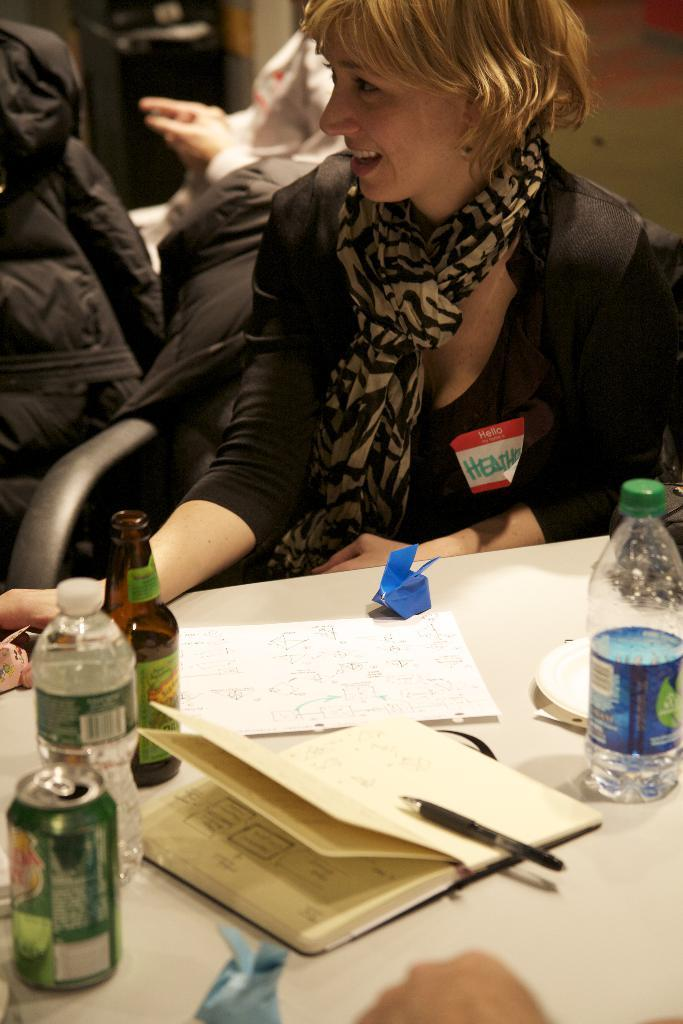What is the woman doing in the image? The woman is sitting on a chair in the image. What is in front of the woman? There is a table in front of the woman. What items can be seen on the table? There is a book, a pen, paper, a beverage can, and a water bottle on the table. What type of glove is the woman wearing in the image? There is no glove visible in the image; the woman is not wearing any gloves. Can you tell me how many pears are present on the table in the image? There are no pears present on the table in the image. 